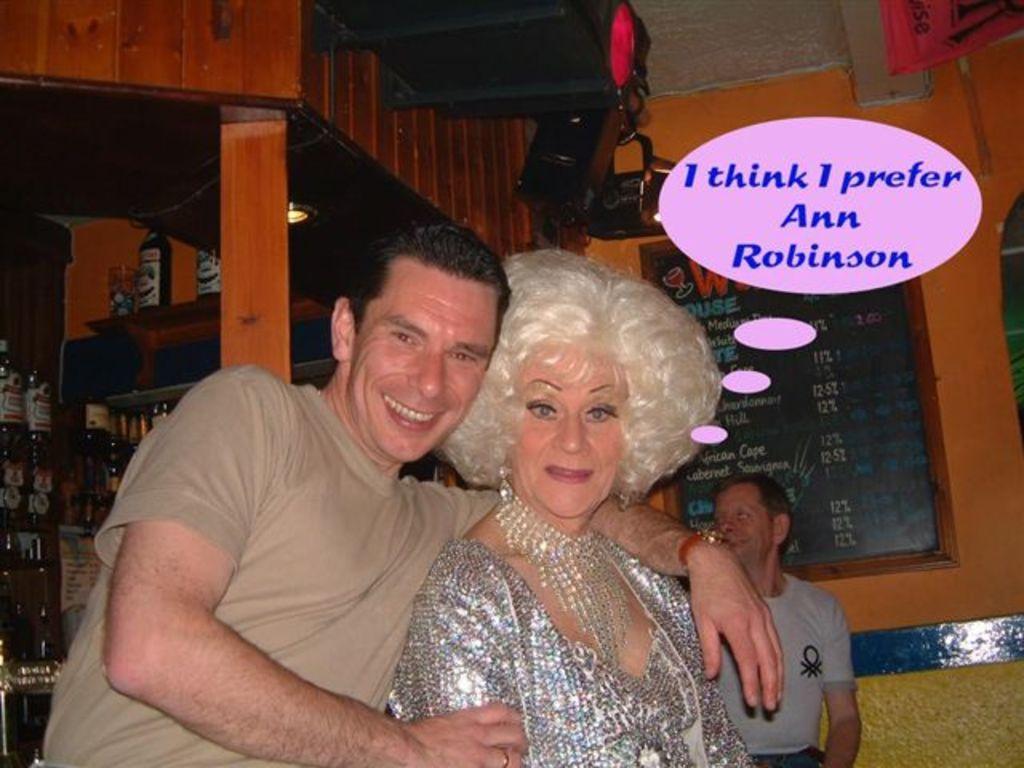Can you describe this image briefly? In this picture we can see a man, woman, they are smiling and in the background we can see a noticeboard on the wall, here we can see a person, bottles, wooden pole, lights and some objects and some text on it. 